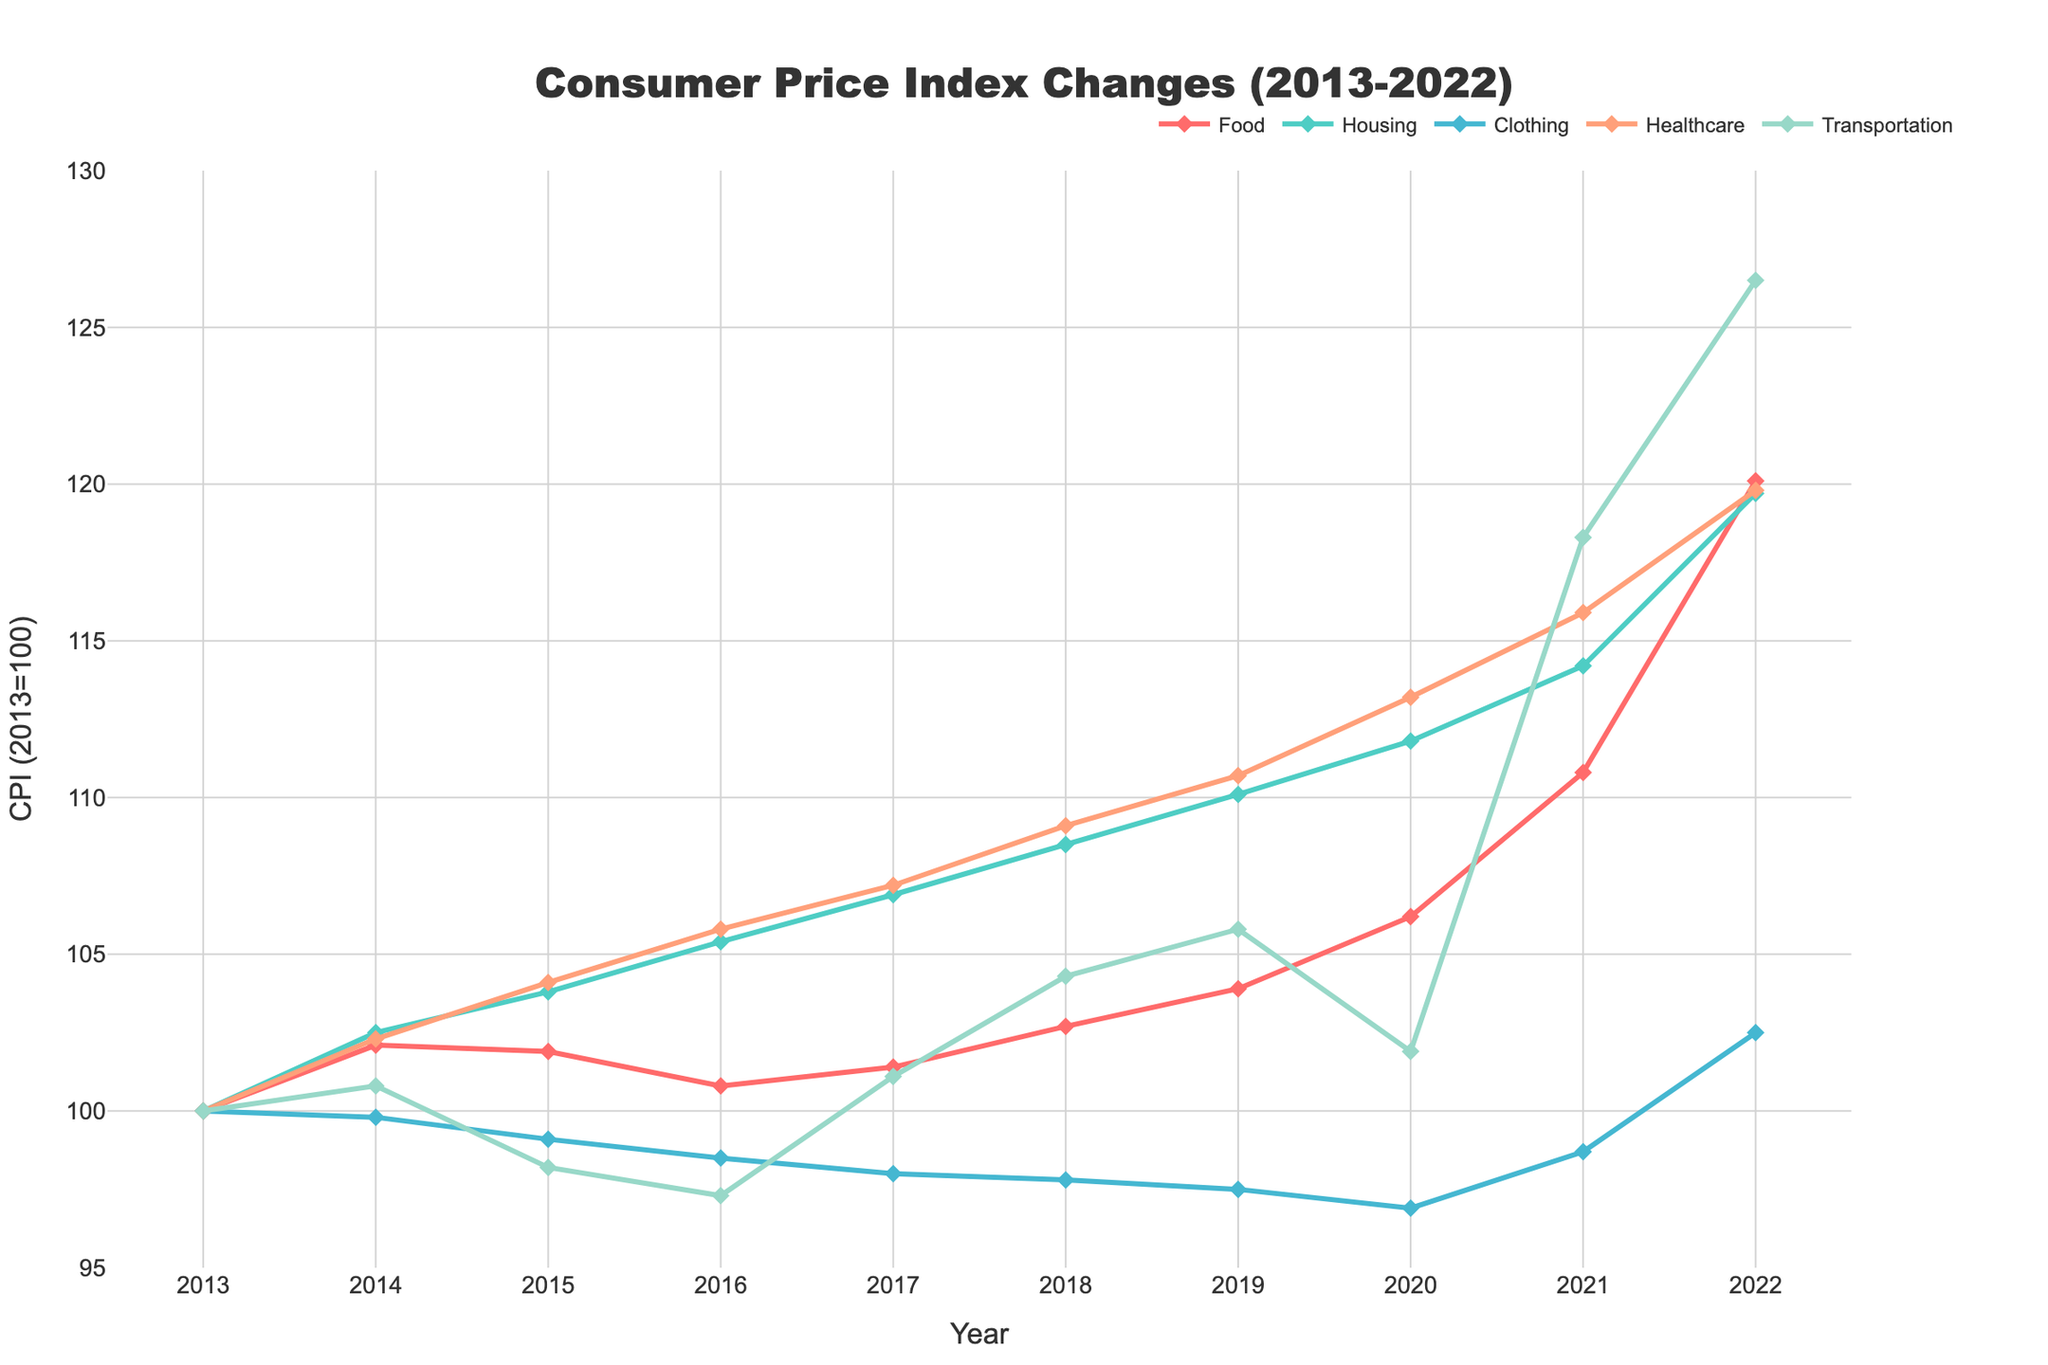Which essential good had the highest Consumer Price Index (CPI) in 2022? Look at the plotted lines for each essential good in 2022. Identify which line reaches the highest CPI value.
Answer: Transportation What is the CPI difference between Food and Housing in the year 2020? Find the CPI values for Food and Housing in 2020. Subtract the CPI value of Housing from that of Food (106.2 - 111.8).
Answer: -5.6 Between 2014 and 2018, did the CPI for Clothing ever increase from one year to the next? If so, in which year(s)? Review the trend of the Clothing line from 2014 to 2018. Check if the values for any year are higher than the previous year. The CPI decreased each year except between 2017 and 2018 where it increased slightly.
Answer: 2018 How much did the Healthcare CPI increase from 2013 to 2022? Compare the Healthcare CPI in 2013 and 2022. Subtract the 2013 value from the 2022 value (119.8 - 100).
Answer: 19.8 Which year saw the lowest CPI for Transportation and what was the value? Look for the trough of the Transportation line throughout the chart. Identify the year corresponding to the lowest point and note the value.
Answer: 2016, 97.3 Compare the overall trend of Housing and Healthcare CPIs from 2013 to 2022. Which one showed a more consistent increase over the years? Analyze the Housing and Healthcare lines from 2013 to 2022. Observe which line showed a steadier upward trend without much fluctuation.
Answer: Healthcare What was the CPI for Food in 2018, and how did it change by 2022? Locate the Food CPI value in 2018 and compare it to the value in 2022. Note the change (120.1 - 102.7).
Answer: 17.4 If the average CPI of all essential goods in 2016 is calculated, what is the value? Sum all the CPIs in 2016 for Food, Housing, Clothing, Healthcare, and Transportation (100.8 + 105.4 + 98.5 + 105.8 + 97.3) and divide by 5. The computed average should be documented.
Answer: 101.56 During which years did the CPI for Food decrease compared to the previous year? Examine the trend of the Food line and identify any years where a decrease is observed compared to the prior year (2015 and 2016).
Answer: 2015, 2016 